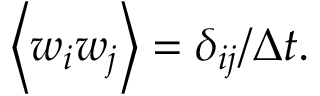Convert formula to latex. <formula><loc_0><loc_0><loc_500><loc_500>\left \langle w _ { i } w _ { j } \right \rangle = \delta _ { i j } / \Delta t .</formula> 